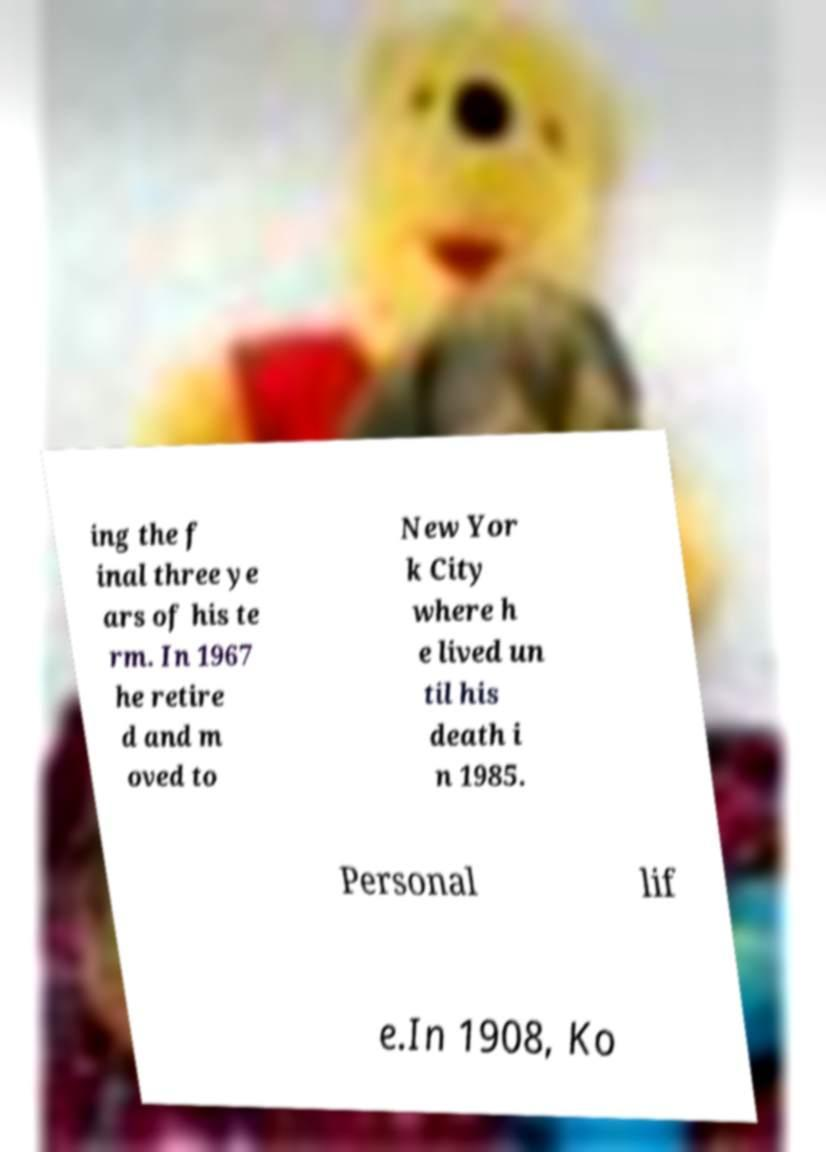What messages or text are displayed in this image? I need them in a readable, typed format. ing the f inal three ye ars of his te rm. In 1967 he retire d and m oved to New Yor k City where h e lived un til his death i n 1985. Personal lif e.In 1908, Ko 